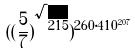Convert formula to latex. <formula><loc_0><loc_0><loc_500><loc_500>( ( \frac { 5 } { 7 } ) ^ { \sqrt { 2 1 5 } } ) ^ { 2 6 0 \cdot 4 1 0 ^ { 2 0 7 } }</formula> 